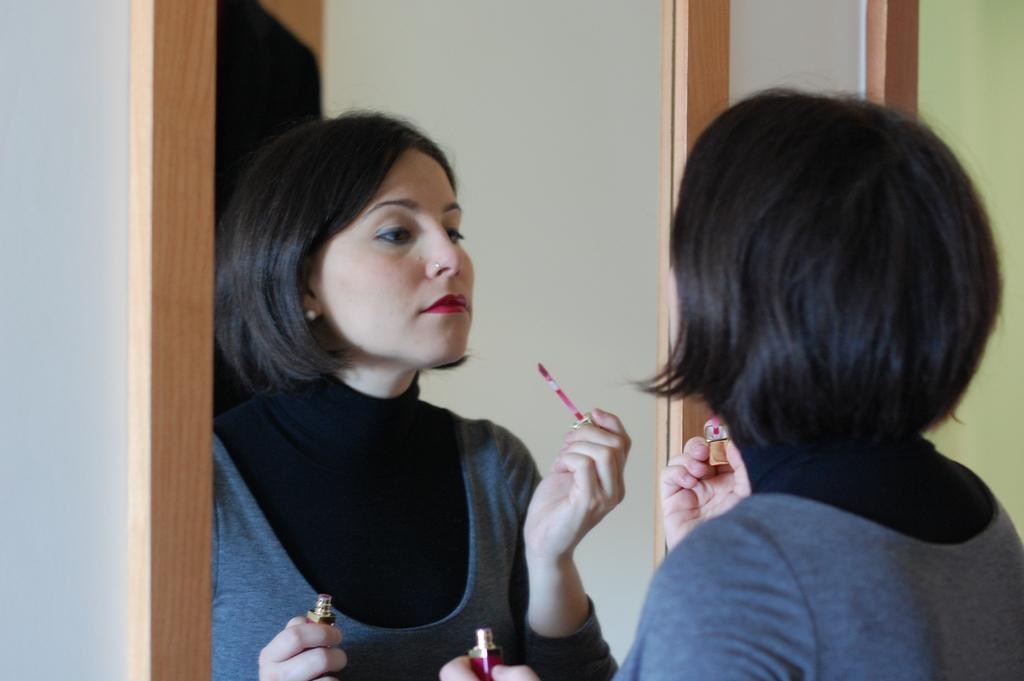What is the person holding in the image? The person is holding lipstick in the image. What object might be used for personal grooming in the image? There is a mirror in the image that can be used for personal grooming. Can you describe the reflection in the mirror? Another person is visible in the mirror. What is the background of the image? There is a wall in the image. What type of property is being sold in the image? There is no indication of any property being sold in the image. 